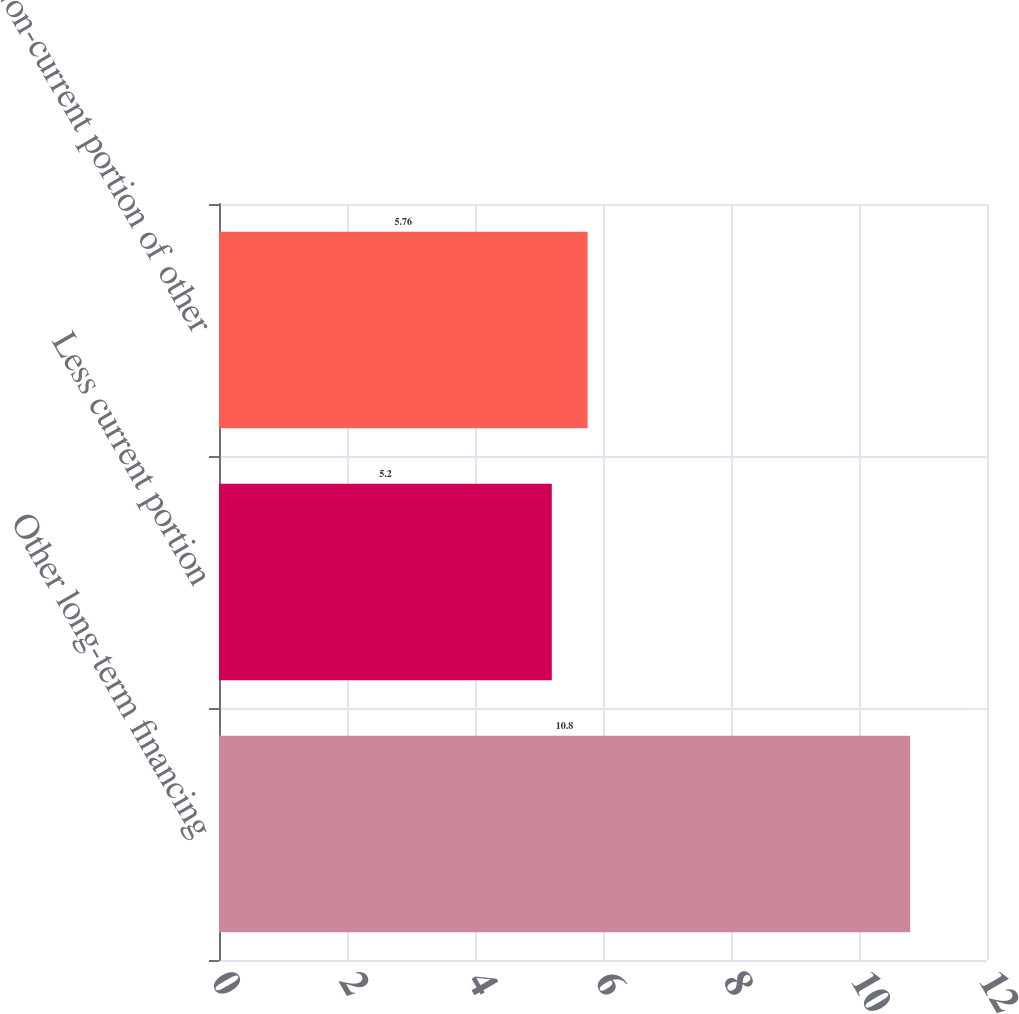Convert chart to OTSL. <chart><loc_0><loc_0><loc_500><loc_500><bar_chart><fcel>Other long-term financing<fcel>Less current portion<fcel>Non-current portion of other<nl><fcel>10.8<fcel>5.2<fcel>5.76<nl></chart> 